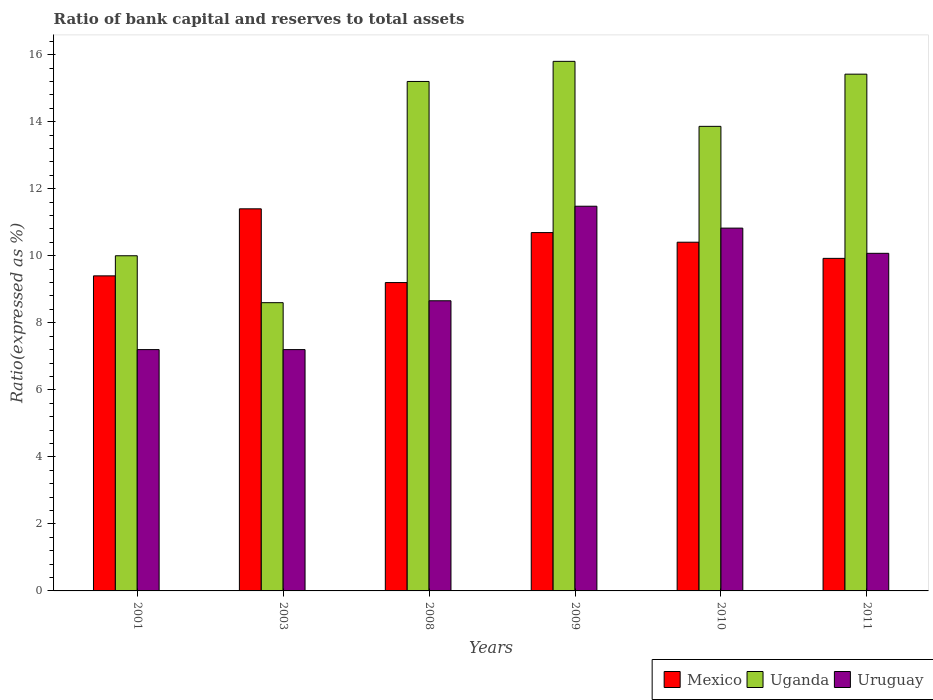How many different coloured bars are there?
Your answer should be very brief. 3. Are the number of bars on each tick of the X-axis equal?
Make the answer very short. Yes. How many bars are there on the 2nd tick from the right?
Keep it short and to the point. 3. What is the label of the 2nd group of bars from the left?
Offer a terse response. 2003. In how many cases, is the number of bars for a given year not equal to the number of legend labels?
Give a very brief answer. 0. What is the ratio of bank capital and reserves to total assets in Mexico in 2003?
Your response must be concise. 11.4. In which year was the ratio of bank capital and reserves to total assets in Uruguay maximum?
Give a very brief answer. 2009. In which year was the ratio of bank capital and reserves to total assets in Uruguay minimum?
Provide a succinct answer. 2001. What is the total ratio of bank capital and reserves to total assets in Mexico in the graph?
Offer a very short reply. 61.02. What is the difference between the ratio of bank capital and reserves to total assets in Uruguay in 2001 and that in 2008?
Offer a terse response. -1.46. What is the difference between the ratio of bank capital and reserves to total assets in Mexico in 2008 and the ratio of bank capital and reserves to total assets in Uruguay in 2001?
Give a very brief answer. 2. What is the average ratio of bank capital and reserves to total assets in Uruguay per year?
Keep it short and to the point. 9.24. In the year 2001, what is the difference between the ratio of bank capital and reserves to total assets in Uganda and ratio of bank capital and reserves to total assets in Mexico?
Offer a terse response. 0.6. What is the ratio of the ratio of bank capital and reserves to total assets in Uganda in 2010 to that in 2011?
Make the answer very short. 0.9. Is the difference between the ratio of bank capital and reserves to total assets in Uganda in 2009 and 2010 greater than the difference between the ratio of bank capital and reserves to total assets in Mexico in 2009 and 2010?
Give a very brief answer. Yes. What is the difference between the highest and the second highest ratio of bank capital and reserves to total assets in Uganda?
Ensure brevity in your answer.  0.38. What is the difference between the highest and the lowest ratio of bank capital and reserves to total assets in Mexico?
Your answer should be very brief. 2.2. In how many years, is the ratio of bank capital and reserves to total assets in Uruguay greater than the average ratio of bank capital and reserves to total assets in Uruguay taken over all years?
Keep it short and to the point. 3. Is the sum of the ratio of bank capital and reserves to total assets in Uruguay in 2009 and 2010 greater than the maximum ratio of bank capital and reserves to total assets in Uganda across all years?
Provide a succinct answer. Yes. What does the 2nd bar from the left in 2003 represents?
Offer a terse response. Uganda. What does the 2nd bar from the right in 2011 represents?
Provide a short and direct response. Uganda. How many bars are there?
Provide a succinct answer. 18. Does the graph contain any zero values?
Provide a short and direct response. No. How many legend labels are there?
Offer a very short reply. 3. What is the title of the graph?
Make the answer very short. Ratio of bank capital and reserves to total assets. Does "Marshall Islands" appear as one of the legend labels in the graph?
Keep it short and to the point. No. What is the label or title of the Y-axis?
Give a very brief answer. Ratio(expressed as %). What is the Ratio(expressed as %) in Mexico in 2008?
Provide a short and direct response. 9.2. What is the Ratio(expressed as %) of Uruguay in 2008?
Your answer should be compact. 8.66. What is the Ratio(expressed as %) in Mexico in 2009?
Make the answer very short. 10.69. What is the Ratio(expressed as %) in Uruguay in 2009?
Your response must be concise. 11.48. What is the Ratio(expressed as %) in Mexico in 2010?
Make the answer very short. 10.4. What is the Ratio(expressed as %) of Uganda in 2010?
Keep it short and to the point. 13.86. What is the Ratio(expressed as %) in Uruguay in 2010?
Provide a short and direct response. 10.82. What is the Ratio(expressed as %) in Mexico in 2011?
Make the answer very short. 9.92. What is the Ratio(expressed as %) in Uganda in 2011?
Give a very brief answer. 15.42. What is the Ratio(expressed as %) in Uruguay in 2011?
Make the answer very short. 10.07. Across all years, what is the maximum Ratio(expressed as %) of Uruguay?
Your response must be concise. 11.48. Across all years, what is the minimum Ratio(expressed as %) of Mexico?
Keep it short and to the point. 9.2. Across all years, what is the minimum Ratio(expressed as %) of Uruguay?
Your answer should be very brief. 7.2. What is the total Ratio(expressed as %) of Mexico in the graph?
Your response must be concise. 61.02. What is the total Ratio(expressed as %) in Uganda in the graph?
Your answer should be very brief. 78.88. What is the total Ratio(expressed as %) in Uruguay in the graph?
Your answer should be very brief. 55.43. What is the difference between the Ratio(expressed as %) of Mexico in 2001 and that in 2003?
Provide a short and direct response. -2. What is the difference between the Ratio(expressed as %) of Uganda in 2001 and that in 2003?
Give a very brief answer. 1.4. What is the difference between the Ratio(expressed as %) of Uganda in 2001 and that in 2008?
Provide a short and direct response. -5.2. What is the difference between the Ratio(expressed as %) of Uruguay in 2001 and that in 2008?
Provide a succinct answer. -1.46. What is the difference between the Ratio(expressed as %) of Mexico in 2001 and that in 2009?
Provide a short and direct response. -1.29. What is the difference between the Ratio(expressed as %) of Uganda in 2001 and that in 2009?
Provide a succinct answer. -5.8. What is the difference between the Ratio(expressed as %) in Uruguay in 2001 and that in 2009?
Offer a very short reply. -4.28. What is the difference between the Ratio(expressed as %) in Mexico in 2001 and that in 2010?
Keep it short and to the point. -1. What is the difference between the Ratio(expressed as %) of Uganda in 2001 and that in 2010?
Offer a very short reply. -3.86. What is the difference between the Ratio(expressed as %) of Uruguay in 2001 and that in 2010?
Your answer should be compact. -3.62. What is the difference between the Ratio(expressed as %) in Mexico in 2001 and that in 2011?
Your answer should be compact. -0.52. What is the difference between the Ratio(expressed as %) in Uganda in 2001 and that in 2011?
Your response must be concise. -5.42. What is the difference between the Ratio(expressed as %) of Uruguay in 2001 and that in 2011?
Keep it short and to the point. -2.87. What is the difference between the Ratio(expressed as %) in Uganda in 2003 and that in 2008?
Your answer should be compact. -6.6. What is the difference between the Ratio(expressed as %) in Uruguay in 2003 and that in 2008?
Your answer should be very brief. -1.46. What is the difference between the Ratio(expressed as %) of Mexico in 2003 and that in 2009?
Offer a terse response. 0.71. What is the difference between the Ratio(expressed as %) of Uruguay in 2003 and that in 2009?
Offer a very short reply. -4.28. What is the difference between the Ratio(expressed as %) in Mexico in 2003 and that in 2010?
Ensure brevity in your answer.  1. What is the difference between the Ratio(expressed as %) of Uganda in 2003 and that in 2010?
Ensure brevity in your answer.  -5.26. What is the difference between the Ratio(expressed as %) in Uruguay in 2003 and that in 2010?
Your answer should be compact. -3.62. What is the difference between the Ratio(expressed as %) of Mexico in 2003 and that in 2011?
Provide a succinct answer. 1.48. What is the difference between the Ratio(expressed as %) of Uganda in 2003 and that in 2011?
Your response must be concise. -6.82. What is the difference between the Ratio(expressed as %) of Uruguay in 2003 and that in 2011?
Your answer should be compact. -2.87. What is the difference between the Ratio(expressed as %) of Mexico in 2008 and that in 2009?
Keep it short and to the point. -1.49. What is the difference between the Ratio(expressed as %) of Uganda in 2008 and that in 2009?
Give a very brief answer. -0.6. What is the difference between the Ratio(expressed as %) in Uruguay in 2008 and that in 2009?
Your answer should be compact. -2.82. What is the difference between the Ratio(expressed as %) in Mexico in 2008 and that in 2010?
Your answer should be very brief. -1.2. What is the difference between the Ratio(expressed as %) of Uganda in 2008 and that in 2010?
Your answer should be compact. 1.34. What is the difference between the Ratio(expressed as %) in Uruguay in 2008 and that in 2010?
Make the answer very short. -2.17. What is the difference between the Ratio(expressed as %) of Mexico in 2008 and that in 2011?
Give a very brief answer. -0.72. What is the difference between the Ratio(expressed as %) in Uganda in 2008 and that in 2011?
Your answer should be very brief. -0.22. What is the difference between the Ratio(expressed as %) of Uruguay in 2008 and that in 2011?
Provide a short and direct response. -1.42. What is the difference between the Ratio(expressed as %) in Mexico in 2009 and that in 2010?
Your response must be concise. 0.29. What is the difference between the Ratio(expressed as %) of Uganda in 2009 and that in 2010?
Offer a terse response. 1.94. What is the difference between the Ratio(expressed as %) of Uruguay in 2009 and that in 2010?
Your answer should be very brief. 0.65. What is the difference between the Ratio(expressed as %) in Mexico in 2009 and that in 2011?
Your response must be concise. 0.77. What is the difference between the Ratio(expressed as %) of Uganda in 2009 and that in 2011?
Your answer should be compact. 0.38. What is the difference between the Ratio(expressed as %) in Uruguay in 2009 and that in 2011?
Ensure brevity in your answer.  1.41. What is the difference between the Ratio(expressed as %) of Mexico in 2010 and that in 2011?
Your answer should be compact. 0.48. What is the difference between the Ratio(expressed as %) of Uganda in 2010 and that in 2011?
Provide a short and direct response. -1.56. What is the difference between the Ratio(expressed as %) of Uruguay in 2010 and that in 2011?
Your response must be concise. 0.75. What is the difference between the Ratio(expressed as %) in Mexico in 2001 and the Ratio(expressed as %) in Uganda in 2003?
Offer a terse response. 0.8. What is the difference between the Ratio(expressed as %) in Mexico in 2001 and the Ratio(expressed as %) in Uruguay in 2008?
Your answer should be compact. 0.74. What is the difference between the Ratio(expressed as %) of Uganda in 2001 and the Ratio(expressed as %) of Uruguay in 2008?
Offer a very short reply. 1.34. What is the difference between the Ratio(expressed as %) of Mexico in 2001 and the Ratio(expressed as %) of Uruguay in 2009?
Your answer should be compact. -2.08. What is the difference between the Ratio(expressed as %) of Uganda in 2001 and the Ratio(expressed as %) of Uruguay in 2009?
Provide a succinct answer. -1.48. What is the difference between the Ratio(expressed as %) in Mexico in 2001 and the Ratio(expressed as %) in Uganda in 2010?
Ensure brevity in your answer.  -4.46. What is the difference between the Ratio(expressed as %) in Mexico in 2001 and the Ratio(expressed as %) in Uruguay in 2010?
Your answer should be very brief. -1.42. What is the difference between the Ratio(expressed as %) in Uganda in 2001 and the Ratio(expressed as %) in Uruguay in 2010?
Provide a short and direct response. -0.82. What is the difference between the Ratio(expressed as %) in Mexico in 2001 and the Ratio(expressed as %) in Uganda in 2011?
Your response must be concise. -6.02. What is the difference between the Ratio(expressed as %) in Mexico in 2001 and the Ratio(expressed as %) in Uruguay in 2011?
Make the answer very short. -0.67. What is the difference between the Ratio(expressed as %) of Uganda in 2001 and the Ratio(expressed as %) of Uruguay in 2011?
Offer a very short reply. -0.07. What is the difference between the Ratio(expressed as %) of Mexico in 2003 and the Ratio(expressed as %) of Uruguay in 2008?
Keep it short and to the point. 2.74. What is the difference between the Ratio(expressed as %) in Uganda in 2003 and the Ratio(expressed as %) in Uruguay in 2008?
Ensure brevity in your answer.  -0.06. What is the difference between the Ratio(expressed as %) of Mexico in 2003 and the Ratio(expressed as %) of Uganda in 2009?
Your answer should be compact. -4.4. What is the difference between the Ratio(expressed as %) in Mexico in 2003 and the Ratio(expressed as %) in Uruguay in 2009?
Your answer should be very brief. -0.08. What is the difference between the Ratio(expressed as %) of Uganda in 2003 and the Ratio(expressed as %) of Uruguay in 2009?
Give a very brief answer. -2.88. What is the difference between the Ratio(expressed as %) of Mexico in 2003 and the Ratio(expressed as %) of Uganda in 2010?
Make the answer very short. -2.46. What is the difference between the Ratio(expressed as %) of Mexico in 2003 and the Ratio(expressed as %) of Uruguay in 2010?
Offer a terse response. 0.58. What is the difference between the Ratio(expressed as %) of Uganda in 2003 and the Ratio(expressed as %) of Uruguay in 2010?
Your response must be concise. -2.22. What is the difference between the Ratio(expressed as %) in Mexico in 2003 and the Ratio(expressed as %) in Uganda in 2011?
Make the answer very short. -4.02. What is the difference between the Ratio(expressed as %) in Mexico in 2003 and the Ratio(expressed as %) in Uruguay in 2011?
Your answer should be very brief. 1.33. What is the difference between the Ratio(expressed as %) in Uganda in 2003 and the Ratio(expressed as %) in Uruguay in 2011?
Your response must be concise. -1.47. What is the difference between the Ratio(expressed as %) in Mexico in 2008 and the Ratio(expressed as %) in Uruguay in 2009?
Give a very brief answer. -2.28. What is the difference between the Ratio(expressed as %) in Uganda in 2008 and the Ratio(expressed as %) in Uruguay in 2009?
Keep it short and to the point. 3.72. What is the difference between the Ratio(expressed as %) of Mexico in 2008 and the Ratio(expressed as %) of Uganda in 2010?
Your answer should be compact. -4.66. What is the difference between the Ratio(expressed as %) of Mexico in 2008 and the Ratio(expressed as %) of Uruguay in 2010?
Offer a terse response. -1.62. What is the difference between the Ratio(expressed as %) of Uganda in 2008 and the Ratio(expressed as %) of Uruguay in 2010?
Provide a succinct answer. 4.38. What is the difference between the Ratio(expressed as %) of Mexico in 2008 and the Ratio(expressed as %) of Uganda in 2011?
Your response must be concise. -6.22. What is the difference between the Ratio(expressed as %) in Mexico in 2008 and the Ratio(expressed as %) in Uruguay in 2011?
Your answer should be very brief. -0.87. What is the difference between the Ratio(expressed as %) of Uganda in 2008 and the Ratio(expressed as %) of Uruguay in 2011?
Your answer should be compact. 5.13. What is the difference between the Ratio(expressed as %) in Mexico in 2009 and the Ratio(expressed as %) in Uganda in 2010?
Provide a short and direct response. -3.17. What is the difference between the Ratio(expressed as %) in Mexico in 2009 and the Ratio(expressed as %) in Uruguay in 2010?
Provide a short and direct response. -0.13. What is the difference between the Ratio(expressed as %) of Uganda in 2009 and the Ratio(expressed as %) of Uruguay in 2010?
Give a very brief answer. 4.98. What is the difference between the Ratio(expressed as %) in Mexico in 2009 and the Ratio(expressed as %) in Uganda in 2011?
Give a very brief answer. -4.73. What is the difference between the Ratio(expressed as %) of Mexico in 2009 and the Ratio(expressed as %) of Uruguay in 2011?
Make the answer very short. 0.62. What is the difference between the Ratio(expressed as %) in Uganda in 2009 and the Ratio(expressed as %) in Uruguay in 2011?
Your answer should be very brief. 5.73. What is the difference between the Ratio(expressed as %) of Mexico in 2010 and the Ratio(expressed as %) of Uganda in 2011?
Your answer should be compact. -5.01. What is the difference between the Ratio(expressed as %) in Mexico in 2010 and the Ratio(expressed as %) in Uruguay in 2011?
Your answer should be compact. 0.33. What is the difference between the Ratio(expressed as %) in Uganda in 2010 and the Ratio(expressed as %) in Uruguay in 2011?
Your answer should be very brief. 3.79. What is the average Ratio(expressed as %) in Mexico per year?
Keep it short and to the point. 10.17. What is the average Ratio(expressed as %) in Uganda per year?
Your answer should be compact. 13.15. What is the average Ratio(expressed as %) in Uruguay per year?
Keep it short and to the point. 9.24. In the year 2001, what is the difference between the Ratio(expressed as %) of Uganda and Ratio(expressed as %) of Uruguay?
Your answer should be very brief. 2.8. In the year 2003, what is the difference between the Ratio(expressed as %) of Mexico and Ratio(expressed as %) of Uganda?
Offer a terse response. 2.8. In the year 2003, what is the difference between the Ratio(expressed as %) of Mexico and Ratio(expressed as %) of Uruguay?
Your answer should be compact. 4.2. In the year 2003, what is the difference between the Ratio(expressed as %) of Uganda and Ratio(expressed as %) of Uruguay?
Make the answer very short. 1.4. In the year 2008, what is the difference between the Ratio(expressed as %) in Mexico and Ratio(expressed as %) in Uruguay?
Keep it short and to the point. 0.54. In the year 2008, what is the difference between the Ratio(expressed as %) in Uganda and Ratio(expressed as %) in Uruguay?
Make the answer very short. 6.54. In the year 2009, what is the difference between the Ratio(expressed as %) of Mexico and Ratio(expressed as %) of Uganda?
Keep it short and to the point. -5.11. In the year 2009, what is the difference between the Ratio(expressed as %) in Mexico and Ratio(expressed as %) in Uruguay?
Give a very brief answer. -0.79. In the year 2009, what is the difference between the Ratio(expressed as %) in Uganda and Ratio(expressed as %) in Uruguay?
Offer a terse response. 4.32. In the year 2010, what is the difference between the Ratio(expressed as %) of Mexico and Ratio(expressed as %) of Uganda?
Give a very brief answer. -3.46. In the year 2010, what is the difference between the Ratio(expressed as %) in Mexico and Ratio(expressed as %) in Uruguay?
Make the answer very short. -0.42. In the year 2010, what is the difference between the Ratio(expressed as %) in Uganda and Ratio(expressed as %) in Uruguay?
Your answer should be compact. 3.04. In the year 2011, what is the difference between the Ratio(expressed as %) in Mexico and Ratio(expressed as %) in Uganda?
Keep it short and to the point. -5.5. In the year 2011, what is the difference between the Ratio(expressed as %) of Mexico and Ratio(expressed as %) of Uruguay?
Give a very brief answer. -0.15. In the year 2011, what is the difference between the Ratio(expressed as %) of Uganda and Ratio(expressed as %) of Uruguay?
Ensure brevity in your answer.  5.35. What is the ratio of the Ratio(expressed as %) of Mexico in 2001 to that in 2003?
Provide a succinct answer. 0.82. What is the ratio of the Ratio(expressed as %) of Uganda in 2001 to that in 2003?
Your answer should be very brief. 1.16. What is the ratio of the Ratio(expressed as %) in Mexico in 2001 to that in 2008?
Provide a short and direct response. 1.02. What is the ratio of the Ratio(expressed as %) in Uganda in 2001 to that in 2008?
Your answer should be compact. 0.66. What is the ratio of the Ratio(expressed as %) in Uruguay in 2001 to that in 2008?
Provide a succinct answer. 0.83. What is the ratio of the Ratio(expressed as %) of Mexico in 2001 to that in 2009?
Make the answer very short. 0.88. What is the ratio of the Ratio(expressed as %) of Uganda in 2001 to that in 2009?
Provide a succinct answer. 0.63. What is the ratio of the Ratio(expressed as %) of Uruguay in 2001 to that in 2009?
Your answer should be very brief. 0.63. What is the ratio of the Ratio(expressed as %) of Mexico in 2001 to that in 2010?
Provide a succinct answer. 0.9. What is the ratio of the Ratio(expressed as %) in Uganda in 2001 to that in 2010?
Offer a very short reply. 0.72. What is the ratio of the Ratio(expressed as %) of Uruguay in 2001 to that in 2010?
Your answer should be compact. 0.67. What is the ratio of the Ratio(expressed as %) of Uganda in 2001 to that in 2011?
Keep it short and to the point. 0.65. What is the ratio of the Ratio(expressed as %) in Uruguay in 2001 to that in 2011?
Your answer should be very brief. 0.71. What is the ratio of the Ratio(expressed as %) of Mexico in 2003 to that in 2008?
Make the answer very short. 1.24. What is the ratio of the Ratio(expressed as %) in Uganda in 2003 to that in 2008?
Provide a short and direct response. 0.57. What is the ratio of the Ratio(expressed as %) in Uruguay in 2003 to that in 2008?
Keep it short and to the point. 0.83. What is the ratio of the Ratio(expressed as %) of Mexico in 2003 to that in 2009?
Keep it short and to the point. 1.07. What is the ratio of the Ratio(expressed as %) of Uganda in 2003 to that in 2009?
Offer a very short reply. 0.54. What is the ratio of the Ratio(expressed as %) of Uruguay in 2003 to that in 2009?
Keep it short and to the point. 0.63. What is the ratio of the Ratio(expressed as %) in Mexico in 2003 to that in 2010?
Your response must be concise. 1.1. What is the ratio of the Ratio(expressed as %) of Uganda in 2003 to that in 2010?
Your answer should be compact. 0.62. What is the ratio of the Ratio(expressed as %) of Uruguay in 2003 to that in 2010?
Give a very brief answer. 0.67. What is the ratio of the Ratio(expressed as %) of Mexico in 2003 to that in 2011?
Give a very brief answer. 1.15. What is the ratio of the Ratio(expressed as %) in Uganda in 2003 to that in 2011?
Your answer should be compact. 0.56. What is the ratio of the Ratio(expressed as %) in Uruguay in 2003 to that in 2011?
Make the answer very short. 0.71. What is the ratio of the Ratio(expressed as %) of Mexico in 2008 to that in 2009?
Your answer should be compact. 0.86. What is the ratio of the Ratio(expressed as %) of Uganda in 2008 to that in 2009?
Make the answer very short. 0.96. What is the ratio of the Ratio(expressed as %) in Uruguay in 2008 to that in 2009?
Your answer should be very brief. 0.75. What is the ratio of the Ratio(expressed as %) of Mexico in 2008 to that in 2010?
Your answer should be compact. 0.88. What is the ratio of the Ratio(expressed as %) of Uganda in 2008 to that in 2010?
Give a very brief answer. 1.1. What is the ratio of the Ratio(expressed as %) of Uruguay in 2008 to that in 2010?
Your answer should be compact. 0.8. What is the ratio of the Ratio(expressed as %) of Mexico in 2008 to that in 2011?
Your answer should be very brief. 0.93. What is the ratio of the Ratio(expressed as %) in Uganda in 2008 to that in 2011?
Give a very brief answer. 0.99. What is the ratio of the Ratio(expressed as %) of Uruguay in 2008 to that in 2011?
Your response must be concise. 0.86. What is the ratio of the Ratio(expressed as %) of Mexico in 2009 to that in 2010?
Offer a terse response. 1.03. What is the ratio of the Ratio(expressed as %) of Uganda in 2009 to that in 2010?
Provide a succinct answer. 1.14. What is the ratio of the Ratio(expressed as %) in Uruguay in 2009 to that in 2010?
Your response must be concise. 1.06. What is the ratio of the Ratio(expressed as %) in Mexico in 2009 to that in 2011?
Offer a terse response. 1.08. What is the ratio of the Ratio(expressed as %) of Uganda in 2009 to that in 2011?
Offer a terse response. 1.02. What is the ratio of the Ratio(expressed as %) of Uruguay in 2009 to that in 2011?
Offer a terse response. 1.14. What is the ratio of the Ratio(expressed as %) in Mexico in 2010 to that in 2011?
Provide a short and direct response. 1.05. What is the ratio of the Ratio(expressed as %) in Uganda in 2010 to that in 2011?
Offer a terse response. 0.9. What is the ratio of the Ratio(expressed as %) in Uruguay in 2010 to that in 2011?
Offer a very short reply. 1.07. What is the difference between the highest and the second highest Ratio(expressed as %) in Mexico?
Give a very brief answer. 0.71. What is the difference between the highest and the second highest Ratio(expressed as %) in Uganda?
Your response must be concise. 0.38. What is the difference between the highest and the second highest Ratio(expressed as %) of Uruguay?
Your response must be concise. 0.65. What is the difference between the highest and the lowest Ratio(expressed as %) in Mexico?
Offer a terse response. 2.2. What is the difference between the highest and the lowest Ratio(expressed as %) in Uganda?
Your response must be concise. 7.2. What is the difference between the highest and the lowest Ratio(expressed as %) of Uruguay?
Your answer should be compact. 4.28. 